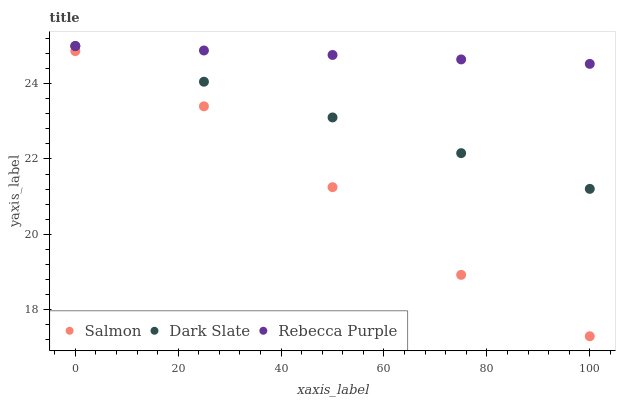Does Salmon have the minimum area under the curve?
Answer yes or no. Yes. Does Rebecca Purple have the maximum area under the curve?
Answer yes or no. Yes. Does Rebecca Purple have the minimum area under the curve?
Answer yes or no. No. Does Salmon have the maximum area under the curve?
Answer yes or no. No. Is Dark Slate the smoothest?
Answer yes or no. Yes. Is Salmon the roughest?
Answer yes or no. Yes. Is Salmon the smoothest?
Answer yes or no. No. Is Rebecca Purple the roughest?
Answer yes or no. No. Does Salmon have the lowest value?
Answer yes or no. Yes. Does Rebecca Purple have the lowest value?
Answer yes or no. No. Does Rebecca Purple have the highest value?
Answer yes or no. Yes. Does Salmon have the highest value?
Answer yes or no. No. Is Salmon less than Rebecca Purple?
Answer yes or no. Yes. Is Rebecca Purple greater than Salmon?
Answer yes or no. Yes. Does Dark Slate intersect Rebecca Purple?
Answer yes or no. Yes. Is Dark Slate less than Rebecca Purple?
Answer yes or no. No. Is Dark Slate greater than Rebecca Purple?
Answer yes or no. No. Does Salmon intersect Rebecca Purple?
Answer yes or no. No. 